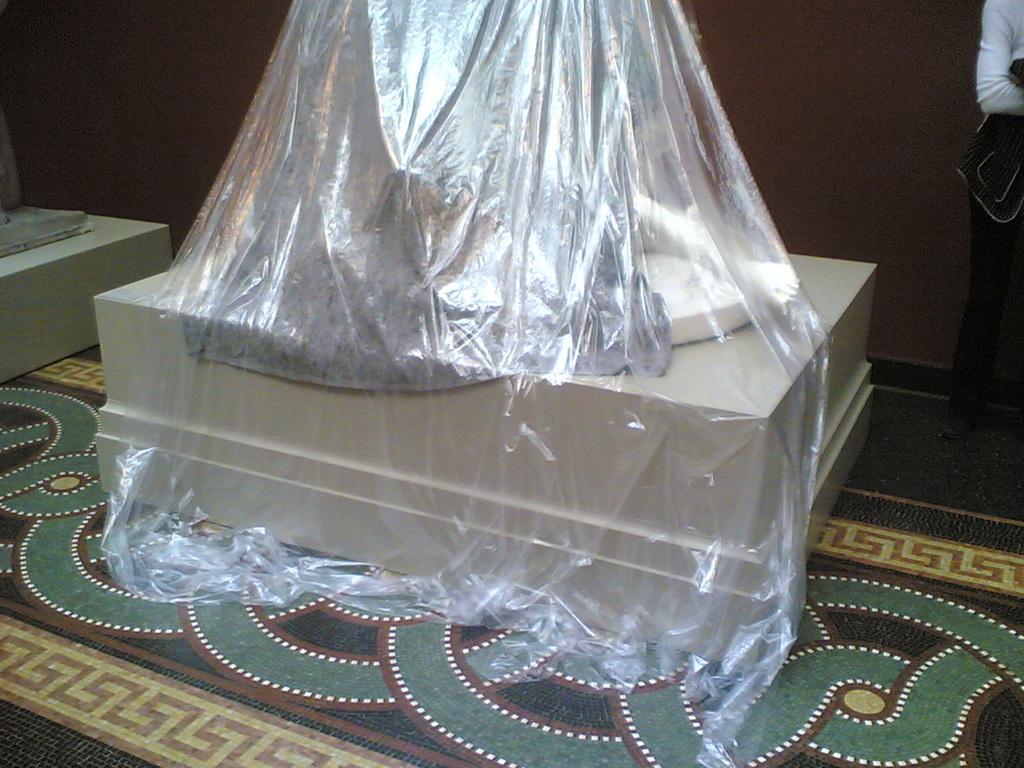How would you summarize this image in a sentence or two? In this image we can see a statue on the stand which is covered with a cover placed on the surface. On the left side we can see the stand. On the right side we can see a person standing. We can also see a wall. 